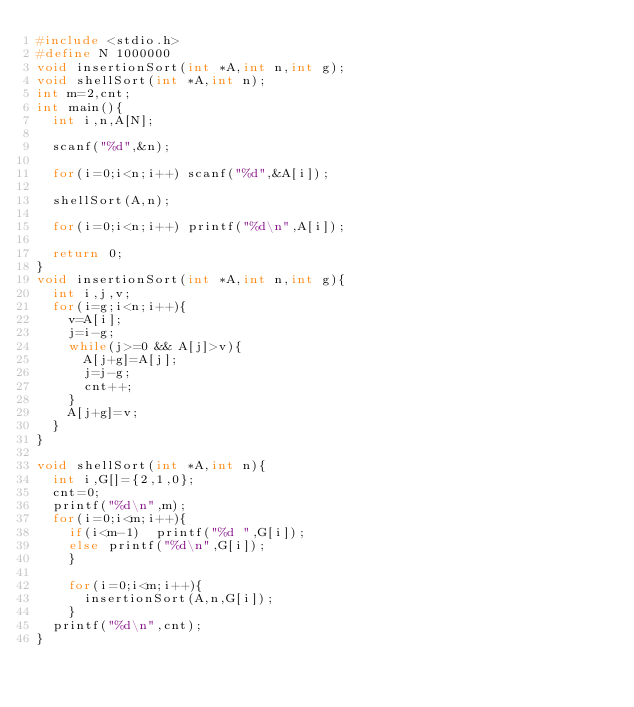Convert code to text. <code><loc_0><loc_0><loc_500><loc_500><_C_>#include <stdio.h>
#define N 1000000
void insertionSort(int *A,int n,int g);
void shellSort(int *A,int n);
int m=2,cnt;
int main(){
  int i,n,A[N];
  
  scanf("%d",&n);
  
  for(i=0;i<n;i++) scanf("%d",&A[i]);
 
  shellSort(A,n);

  for(i=0;i<n;i++) printf("%d\n",A[i]);
  
  return 0;
}
void insertionSort(int *A,int n,int g){
  int i,j,v;
  for(i=g;i<n;i++){
    v=A[i];
    j=i-g;
    while(j>=0 && A[j]>v){
      A[j+g]=A[j];
      j=j-g;
      cnt++;
    }
    A[j+g]=v;
  }
}

void shellSort(int *A,int n){
  int i,G[]={2,1,0};
  cnt=0;
  printf("%d\n",m);
  for(i=0;i<m;i++){
    if(i<m-1)  printf("%d ",G[i]);
    else printf("%d\n",G[i]);
    }
  
    for(i=0;i<m;i++){
      insertionSort(A,n,G[i]);
    }
  printf("%d\n",cnt);
}</code> 